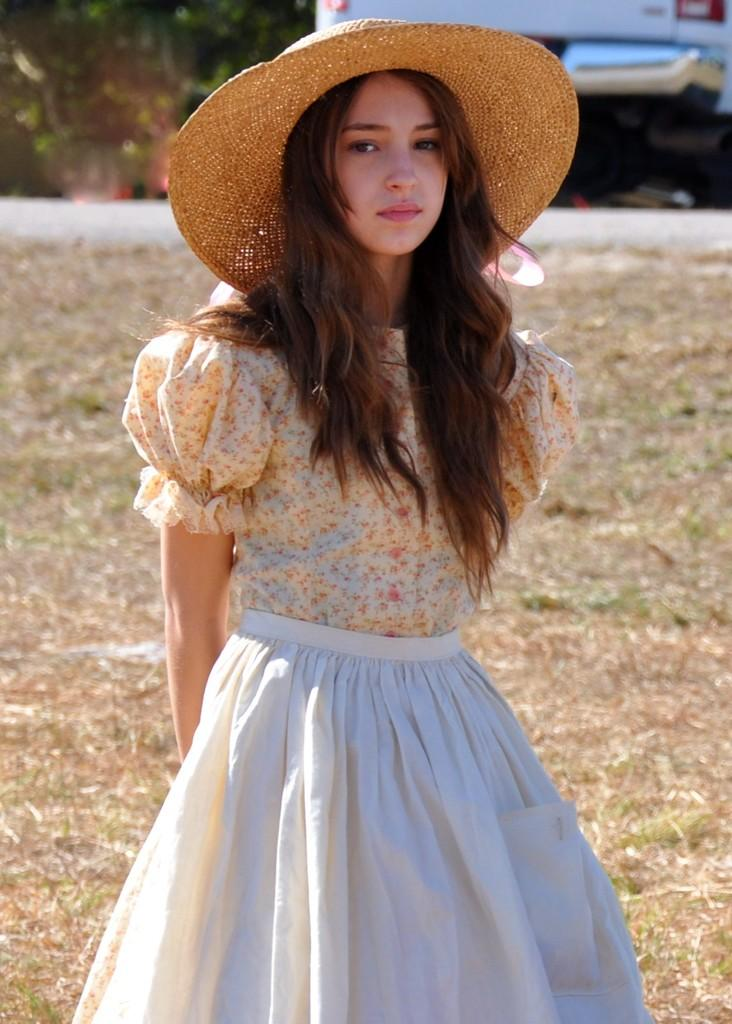Who is the main subject in the image? There is a lady in the image. What is the lady wearing on her head? The lady is wearing a hat. What can be seen in the background of the image? There is a vehicle in the background of the image. How is the vehicle depicted in the image? The vehicle is blurred. What type of corn is being harvested in the image? There is no corn or any indication of harvesting in the image. 